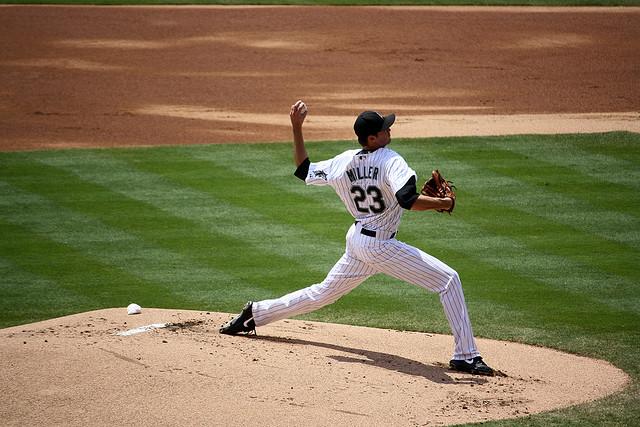What is the man doing with the glove?
Short answer required. Holding. Is the man wearing Nike shoes?
Keep it brief. Yes. What is the number on the uniform?
Give a very brief answer. 23. Which foot has a pronounced pointed toe?
Be succinct. Left. What is his number?
Be succinct. 23. Is this a little league game?
Keep it brief. No. 